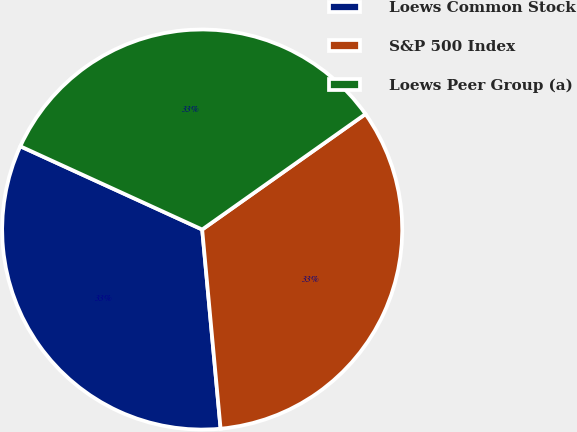Convert chart. <chart><loc_0><loc_0><loc_500><loc_500><pie_chart><fcel>Loews Common Stock<fcel>S&P 500 Index<fcel>Loews Peer Group (a)<nl><fcel>33.3%<fcel>33.33%<fcel>33.37%<nl></chart> 